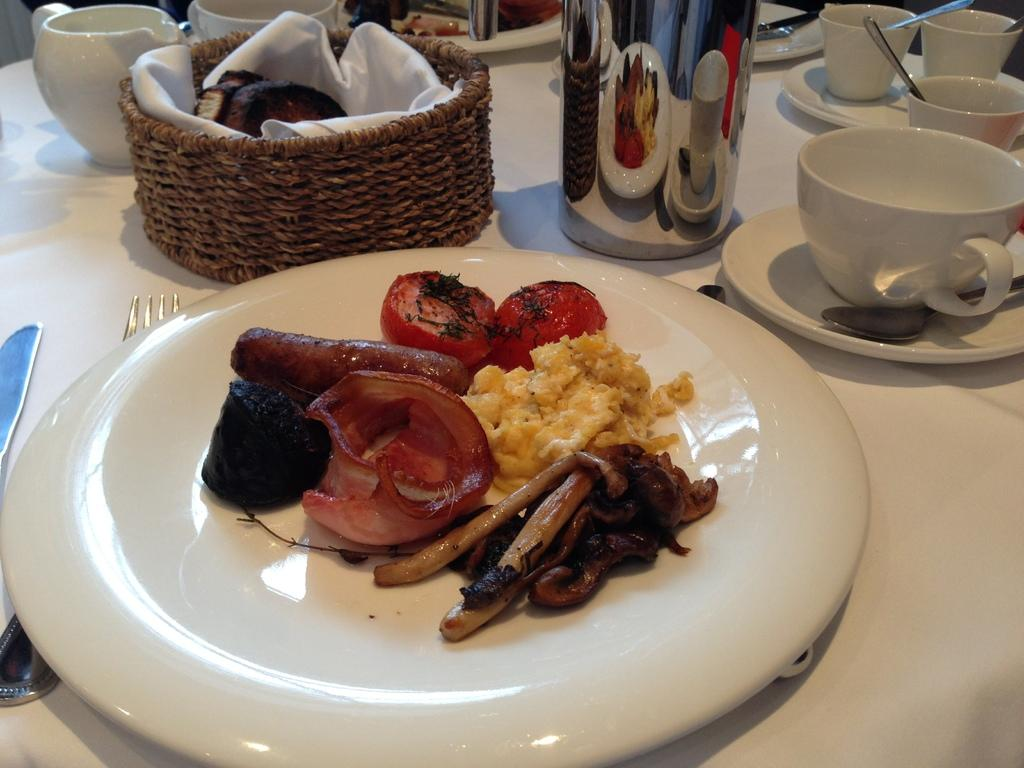What is the main object in the center of the image? There is a table in the center of the image. What is placed on the table? On the table, there is a cloth, a fork, a knife, a mug, a basket, cups, plates, saucers, spoons, and food items. Can you describe the utensils on the table? There is a fork, a knife, and spoons on the table. What type of containers are on the table? There is a mug, cups, and a basket on the table. What type of dishware is on the table? There are plates and saucers on the table. What type of food items can be seen on the table? There are food items on the table. Are there any other objects on the table besides the ones mentioned? Yes, there are other objects on the table. What type of land can be seen in the image? There is no land visible in the image; it is a table setting with various objects on it. What observations can be made about the secretary in the image? There is no secretary present in the image; it is a table setting with various objects on it. 